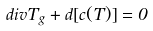<formula> <loc_0><loc_0><loc_500><loc_500>d i v T _ { g } + d [ c ( T ) ] = 0</formula> 